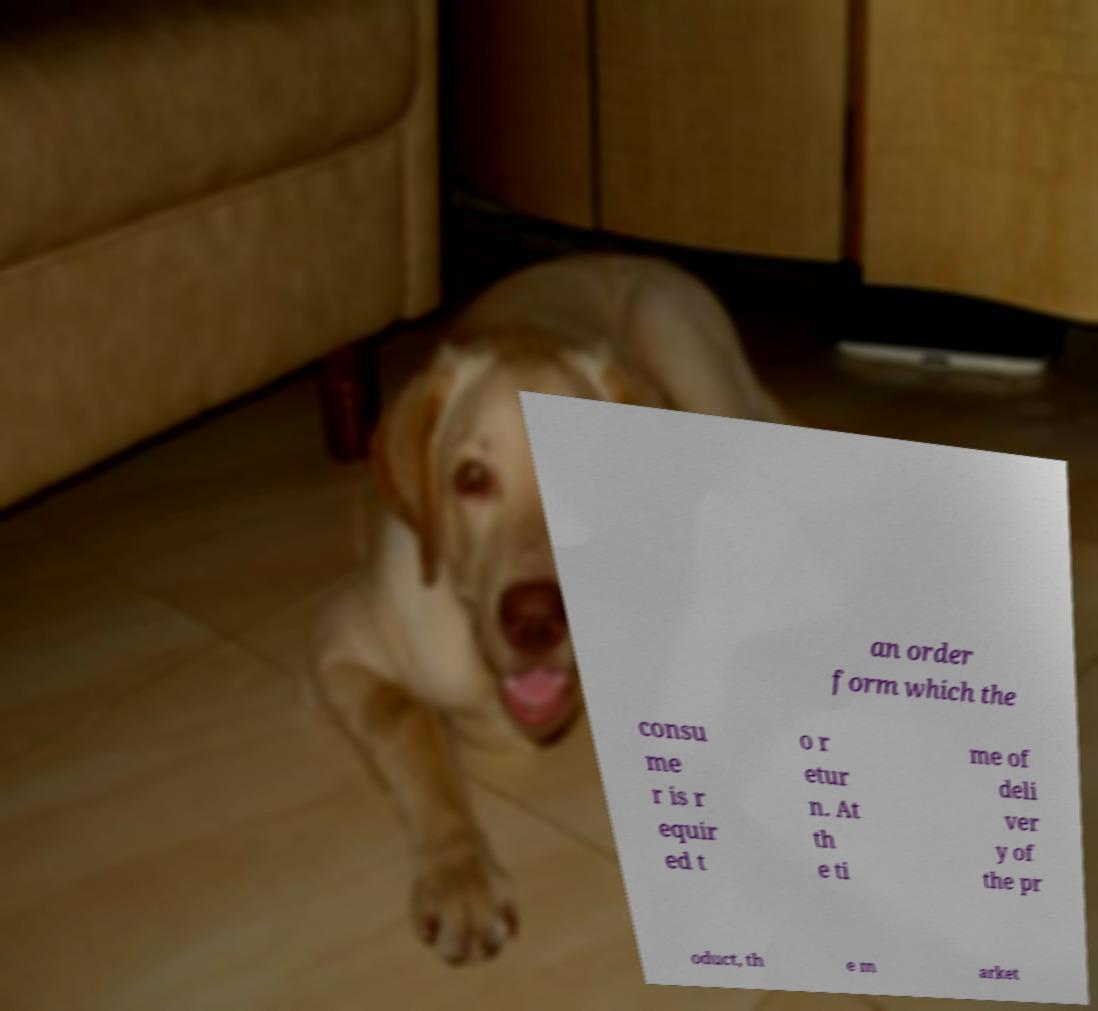Can you read and provide the text displayed in the image?This photo seems to have some interesting text. Can you extract and type it out for me? an order form which the consu me r is r equir ed t o r etur n. At th e ti me of deli ver y of the pr oduct, th e m arket 